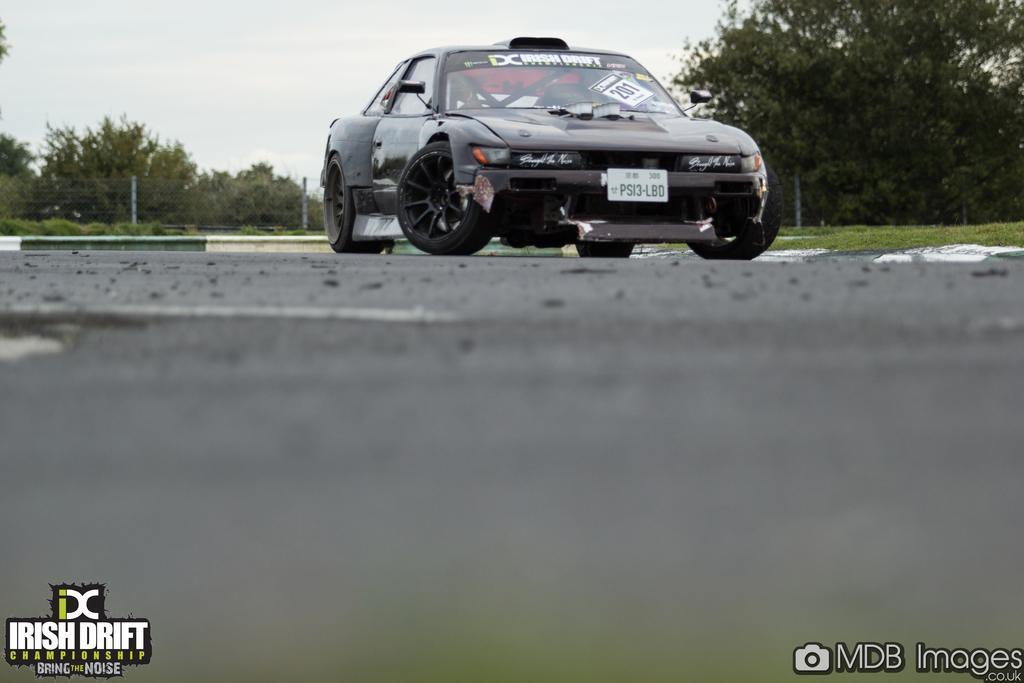Can you describe this image briefly? This is an outside view. Here I can see a racing car on the road. In the background there are many trees. At the top of the image I can see the sky. At the bottom there is some edited text. 